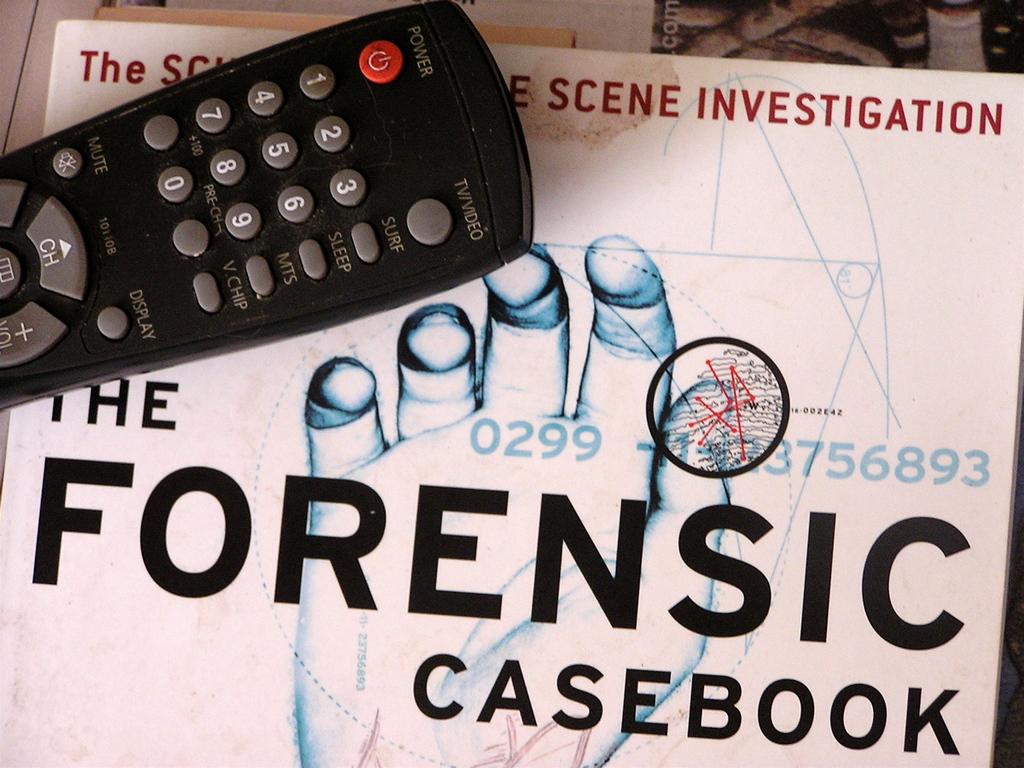What type of casebook is this?
Provide a succinct answer. Forensic. What color are the numbers in the text?
Keep it short and to the point. Blue. 